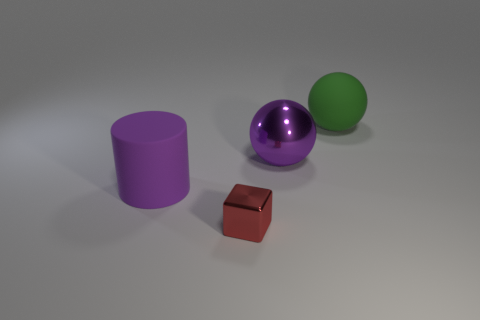Add 2 tiny red metallic balls. How many objects exist? 6 Subtract all cubes. How many objects are left? 3 Subtract 1 red cubes. How many objects are left? 3 Subtract all small red metal balls. Subtract all large purple things. How many objects are left? 2 Add 4 small things. How many small things are left? 5 Add 1 tiny spheres. How many tiny spheres exist? 1 